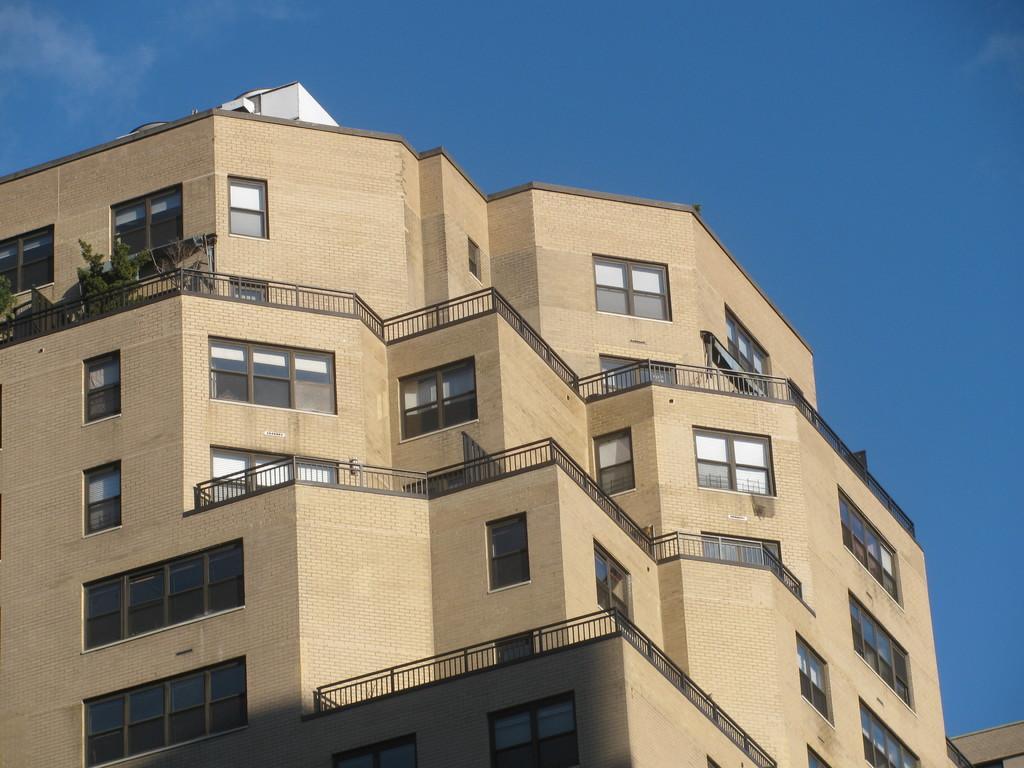Describe this image in one or two sentences. In this image we can see the building with the glass windows and plants. Sky is also visible. 